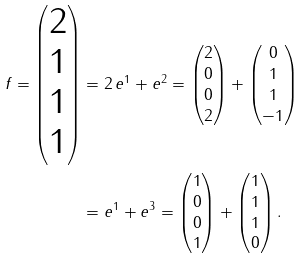Convert formula to latex. <formula><loc_0><loc_0><loc_500><loc_500>f = \begin{pmatrix} 2 \\ 1 \\ 1 \\ 1 \end{pmatrix} & = 2 \, e ^ { 1 } + e ^ { 2 } = \begin{pmatrix} 2 \\ 0 \\ 0 \\ 2 \end{pmatrix} + \begin{pmatrix} 0 \\ 1 \\ 1 \\ - 1 \end{pmatrix} \\ & = e ^ { 1 } + e ^ { 3 } = \begin{pmatrix} 1 \\ 0 \\ 0 \\ 1 \end{pmatrix} + \begin{pmatrix} 1 \\ 1 \\ 1 \\ 0 \end{pmatrix} .</formula> 